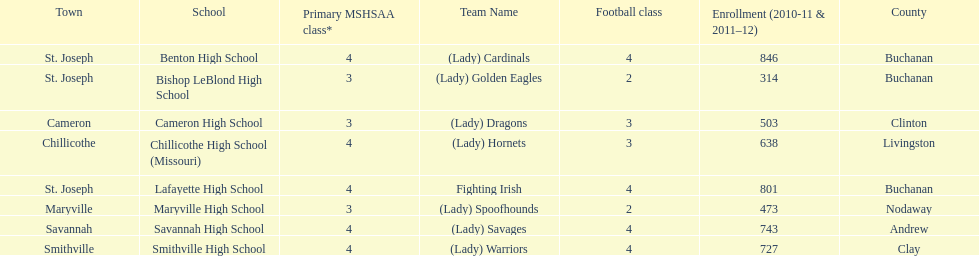What is the number of football classes lafayette high school has? 4. 